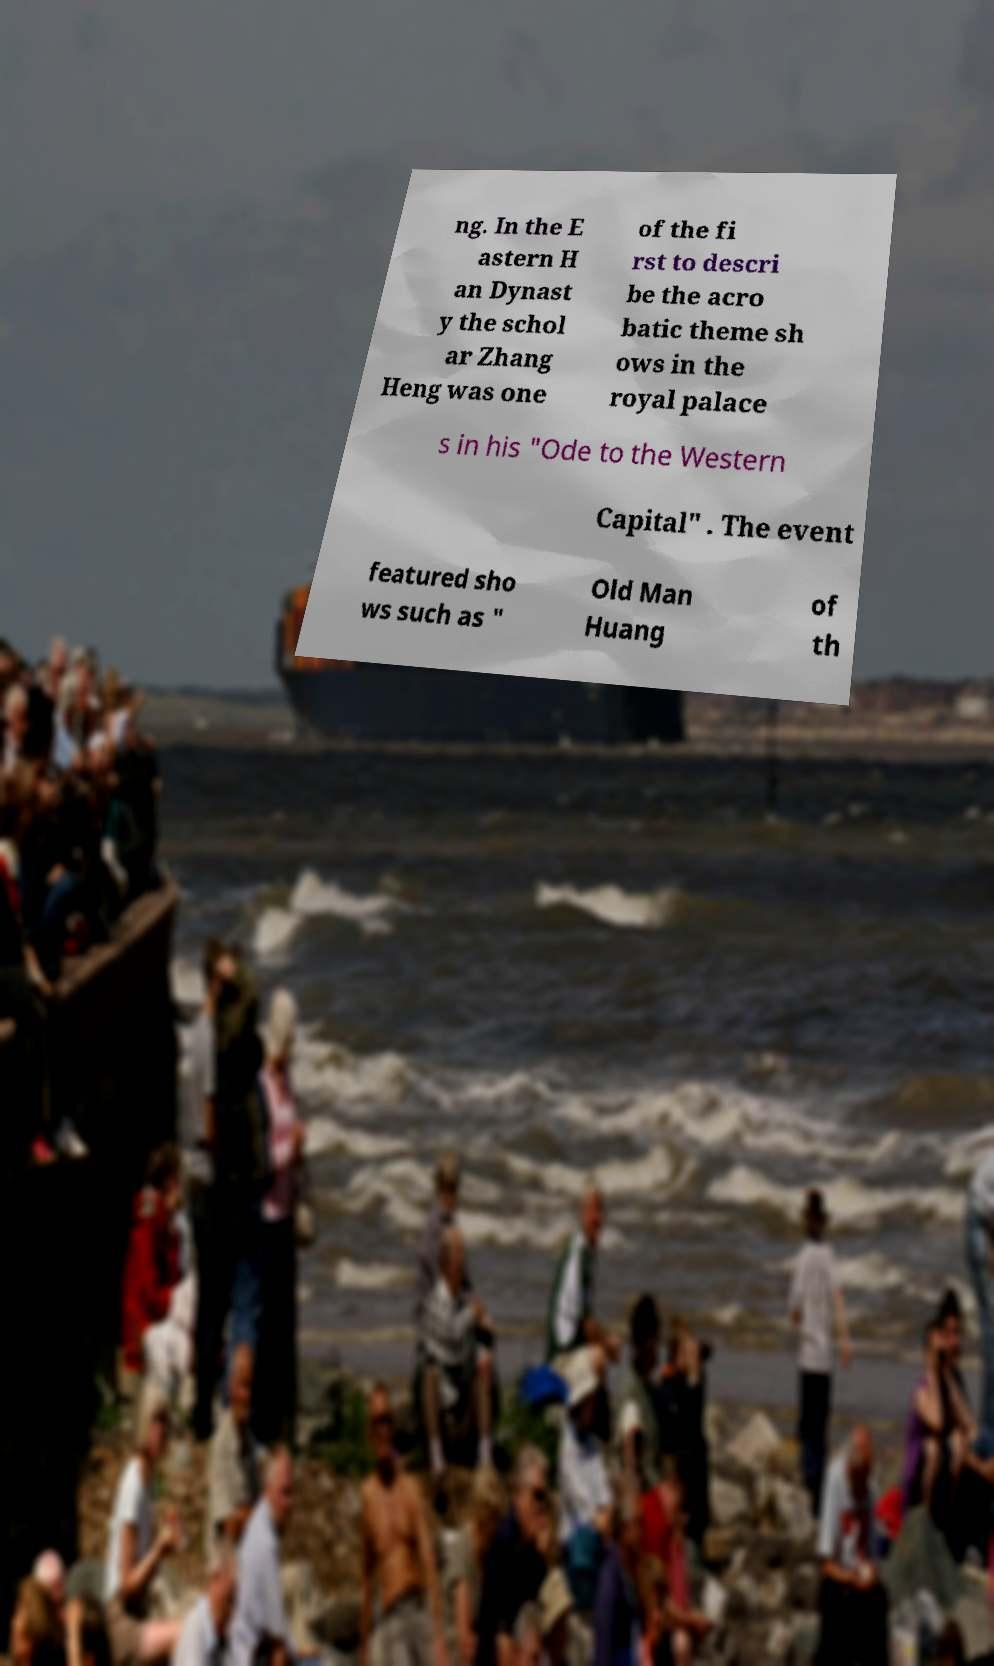For documentation purposes, I need the text within this image transcribed. Could you provide that? ng. In the E astern H an Dynast y the schol ar Zhang Heng was one of the fi rst to descri be the acro batic theme sh ows in the royal palace s in his "Ode to the Western Capital" . The event featured sho ws such as " Old Man Huang of th 